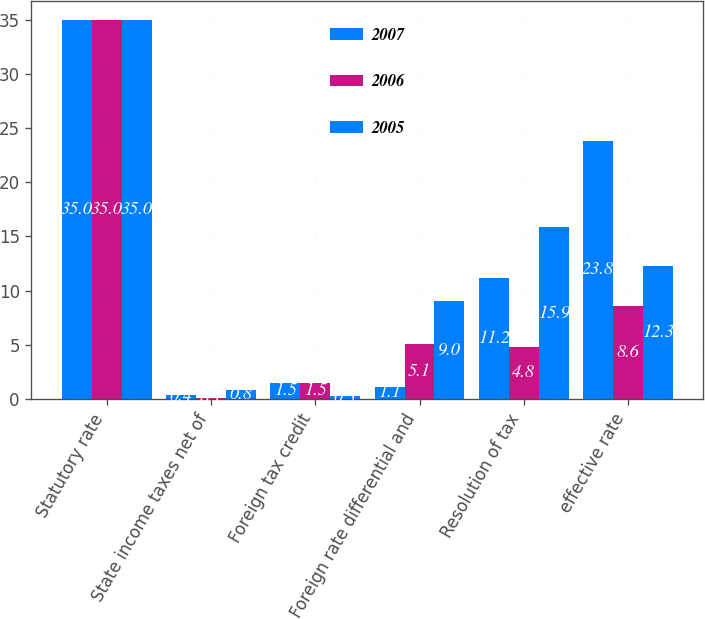Convert chart to OTSL. <chart><loc_0><loc_0><loc_500><loc_500><stacked_bar_chart><ecel><fcel>Statutory rate<fcel>State income taxes net of<fcel>Foreign tax credit<fcel>Foreign rate differential and<fcel>Resolution of tax<fcel>effective rate<nl><fcel>2007<fcel>35<fcel>0.4<fcel>1.5<fcel>1.1<fcel>11.2<fcel>23.8<nl><fcel>2006<fcel>35<fcel>0.1<fcel>1.5<fcel>5.1<fcel>4.8<fcel>8.6<nl><fcel>2005<fcel>35<fcel>0.8<fcel>0.3<fcel>9<fcel>15.9<fcel>12.3<nl></chart> 